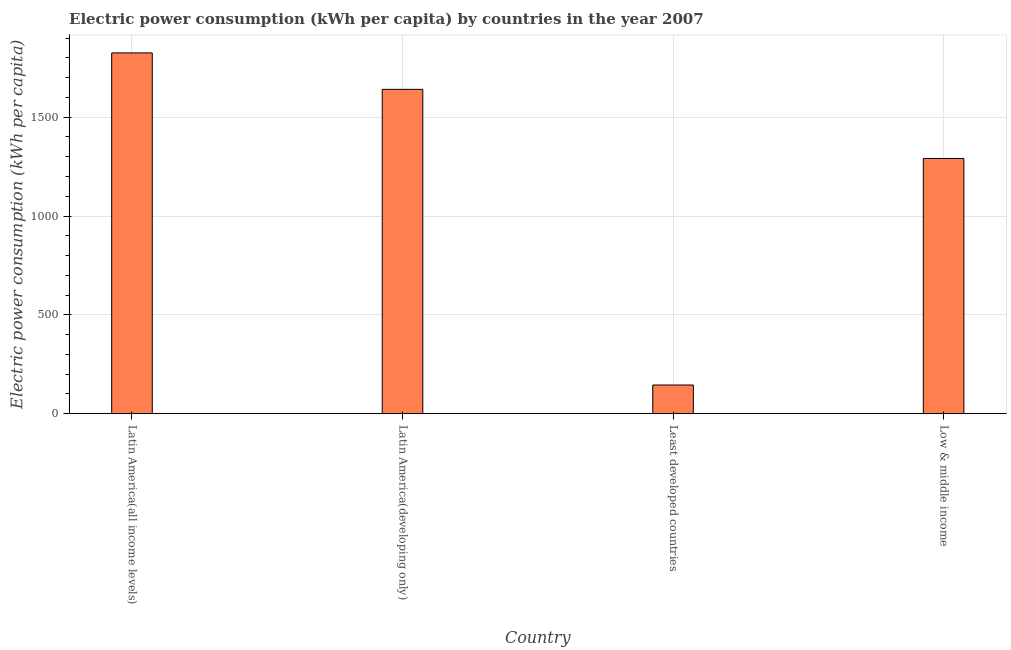Does the graph contain any zero values?
Ensure brevity in your answer.  No. What is the title of the graph?
Ensure brevity in your answer.  Electric power consumption (kWh per capita) by countries in the year 2007. What is the label or title of the Y-axis?
Offer a very short reply. Electric power consumption (kWh per capita). What is the electric power consumption in Low & middle income?
Provide a succinct answer. 1291.03. Across all countries, what is the maximum electric power consumption?
Your answer should be compact. 1824.94. Across all countries, what is the minimum electric power consumption?
Provide a short and direct response. 145.28. In which country was the electric power consumption maximum?
Ensure brevity in your answer.  Latin America(all income levels). In which country was the electric power consumption minimum?
Ensure brevity in your answer.  Least developed countries. What is the sum of the electric power consumption?
Your answer should be very brief. 4901.89. What is the difference between the electric power consumption in Least developed countries and Low & middle income?
Your answer should be compact. -1145.75. What is the average electric power consumption per country?
Offer a terse response. 1225.47. What is the median electric power consumption?
Offer a very short reply. 1465.83. What is the ratio of the electric power consumption in Latin America(all income levels) to that in Latin America(developing only)?
Your response must be concise. 1.11. Is the electric power consumption in Latin America(all income levels) less than that in Low & middle income?
Ensure brevity in your answer.  No. What is the difference between the highest and the second highest electric power consumption?
Your answer should be compact. 184.31. Is the sum of the electric power consumption in Latin America(all income levels) and Low & middle income greater than the maximum electric power consumption across all countries?
Your answer should be compact. Yes. What is the difference between the highest and the lowest electric power consumption?
Your response must be concise. 1679.66. Are all the bars in the graph horizontal?
Offer a terse response. No. How many countries are there in the graph?
Provide a succinct answer. 4. Are the values on the major ticks of Y-axis written in scientific E-notation?
Offer a very short reply. No. What is the Electric power consumption (kWh per capita) of Latin America(all income levels)?
Keep it short and to the point. 1824.94. What is the Electric power consumption (kWh per capita) in Latin America(developing only)?
Your answer should be compact. 1640.63. What is the Electric power consumption (kWh per capita) of Least developed countries?
Your answer should be compact. 145.28. What is the Electric power consumption (kWh per capita) in Low & middle income?
Ensure brevity in your answer.  1291.03. What is the difference between the Electric power consumption (kWh per capita) in Latin America(all income levels) and Latin America(developing only)?
Your answer should be compact. 184.31. What is the difference between the Electric power consumption (kWh per capita) in Latin America(all income levels) and Least developed countries?
Make the answer very short. 1679.66. What is the difference between the Electric power consumption (kWh per capita) in Latin America(all income levels) and Low & middle income?
Your response must be concise. 533.92. What is the difference between the Electric power consumption (kWh per capita) in Latin America(developing only) and Least developed countries?
Offer a terse response. 1495.35. What is the difference between the Electric power consumption (kWh per capita) in Latin America(developing only) and Low & middle income?
Offer a terse response. 349.61. What is the difference between the Electric power consumption (kWh per capita) in Least developed countries and Low & middle income?
Make the answer very short. -1145.75. What is the ratio of the Electric power consumption (kWh per capita) in Latin America(all income levels) to that in Latin America(developing only)?
Ensure brevity in your answer.  1.11. What is the ratio of the Electric power consumption (kWh per capita) in Latin America(all income levels) to that in Least developed countries?
Give a very brief answer. 12.56. What is the ratio of the Electric power consumption (kWh per capita) in Latin America(all income levels) to that in Low & middle income?
Keep it short and to the point. 1.41. What is the ratio of the Electric power consumption (kWh per capita) in Latin America(developing only) to that in Least developed countries?
Provide a short and direct response. 11.29. What is the ratio of the Electric power consumption (kWh per capita) in Latin America(developing only) to that in Low & middle income?
Your answer should be very brief. 1.27. What is the ratio of the Electric power consumption (kWh per capita) in Least developed countries to that in Low & middle income?
Offer a very short reply. 0.11. 